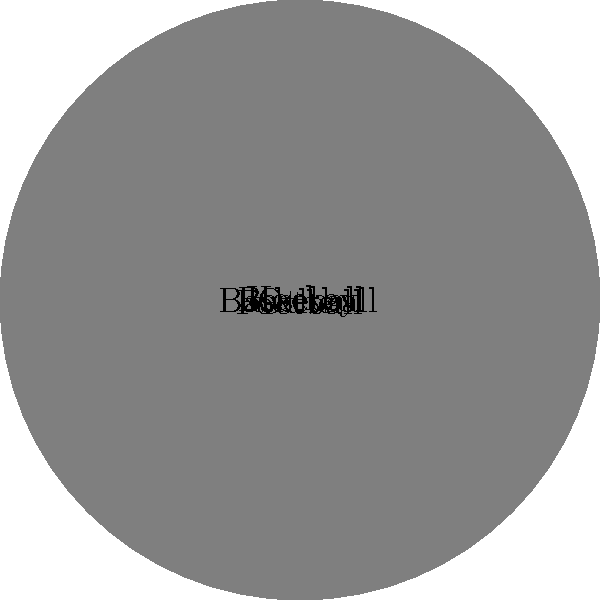Based on the pie chart showing radio listener demographics for various sports in New York, which sport has the second-highest percentage of listeners, and what is the difference in percentage points between it and the most popular sport? To answer this question, we need to follow these steps:

1. Identify the sport with the highest percentage of listeners:
   - Baseball has the largest slice, representing 35% of listeners.

2. Identify the sport with the second-highest percentage:
   - Basketball has the second-largest slice, representing 25% of listeners.

3. Calculate the difference in percentage points:
   - Difference = Percentage of most popular sport - Percentage of second most popular sport
   - Difference = 35% - 25% = 10 percentage points

Therefore, basketball is the sport with the second-highest percentage of listeners, and the difference between it and baseball (the most popular sport) is 10 percentage points.
Answer: Basketball; 10 percentage points 